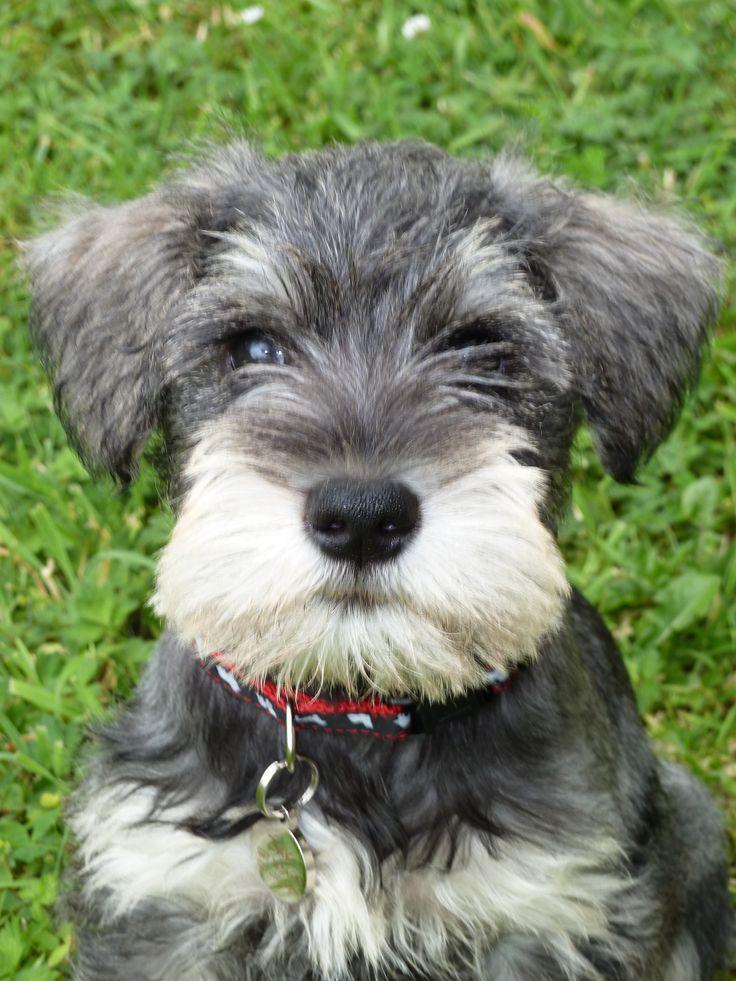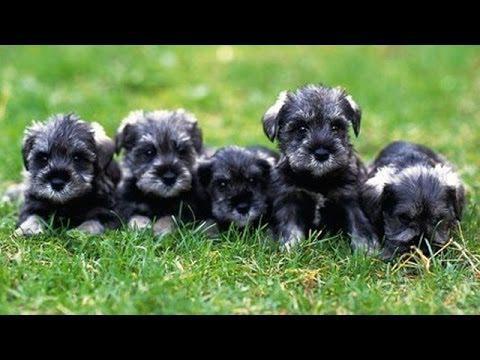The first image is the image on the left, the second image is the image on the right. Analyze the images presented: Is the assertion "There is a single dog sitting in the grass in one of the images." valid? Answer yes or no. Yes. The first image is the image on the left, the second image is the image on the right. Considering the images on both sides, is "An image shows one forward facing dog wearing a red collar." valid? Answer yes or no. Yes. 